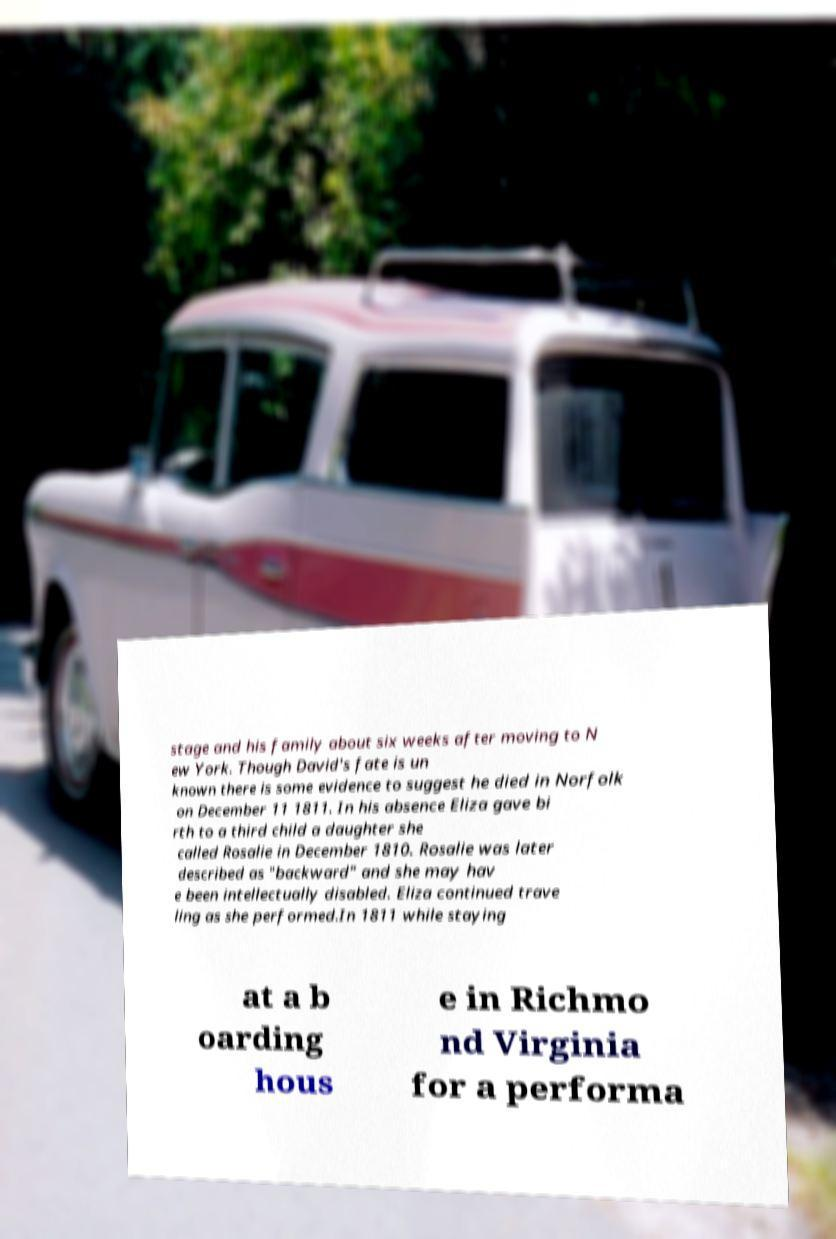I need the written content from this picture converted into text. Can you do that? stage and his family about six weeks after moving to N ew York. Though David's fate is un known there is some evidence to suggest he died in Norfolk on December 11 1811. In his absence Eliza gave bi rth to a third child a daughter she called Rosalie in December 1810. Rosalie was later described as "backward" and she may hav e been intellectually disabled. Eliza continued trave ling as she performed.In 1811 while staying at a b oarding hous e in Richmo nd Virginia for a performa 